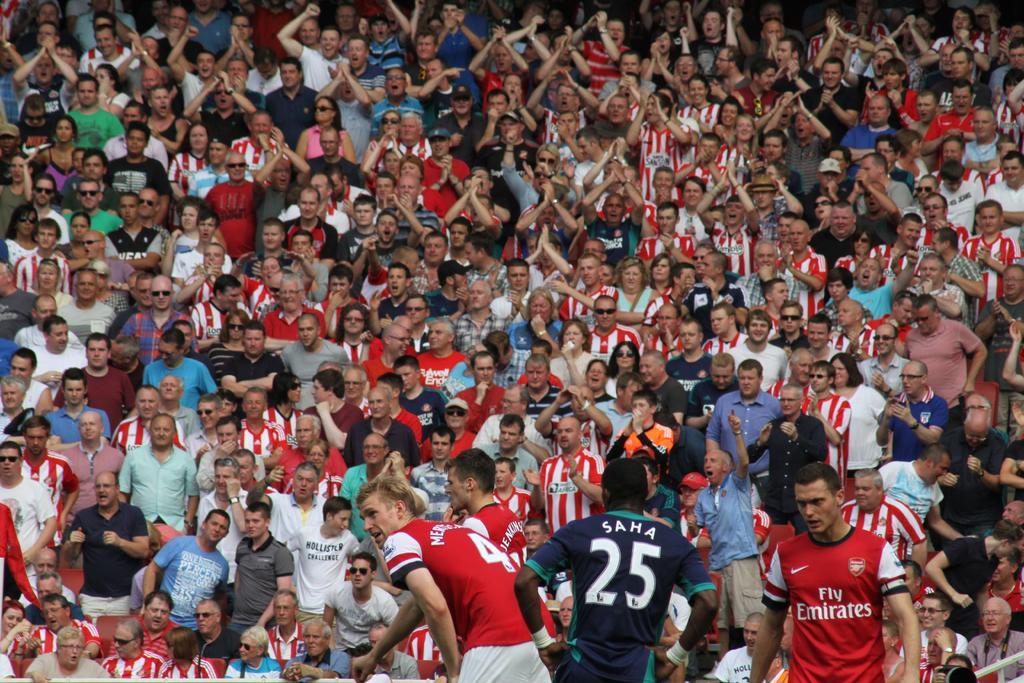Can you describe this image briefly? This image consists of a crowd in the stadium. This image is taken during a day may be in the stadium. 